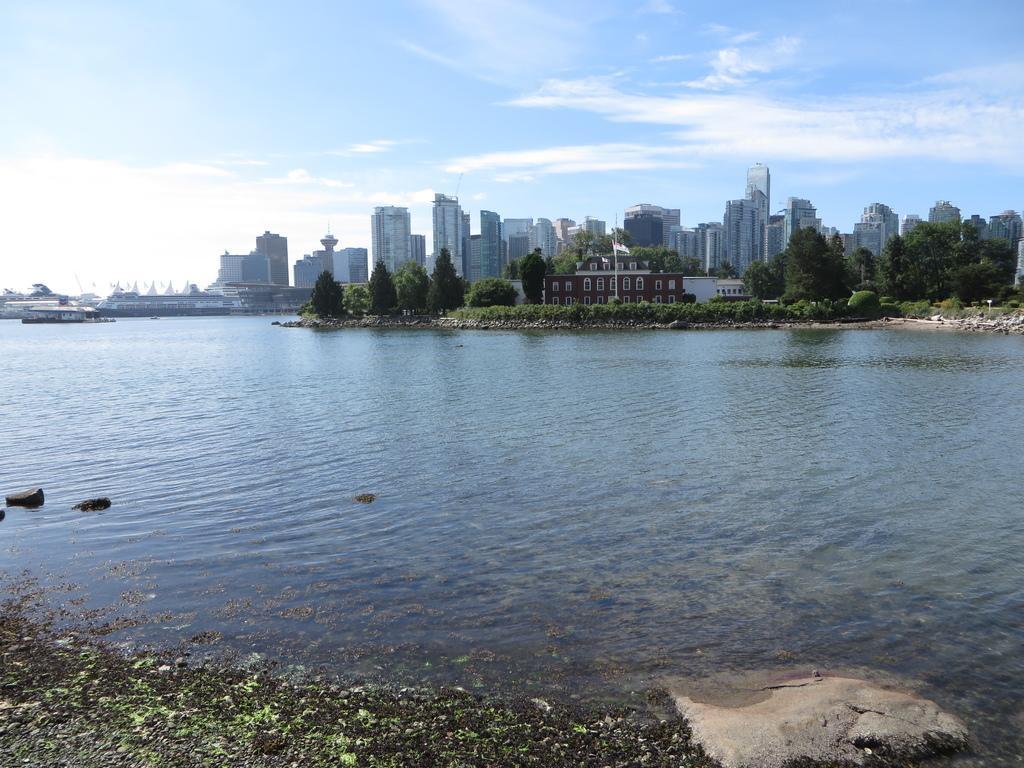In one or two sentences, can you explain what this image depicts? This picture is clicked outside the city. In the foreground we can see the water body. In the center we can see the building, towers, skyscrapers, trees, flag, plants, grass, ships in the water body and some other objects. In the background there is a sky. 